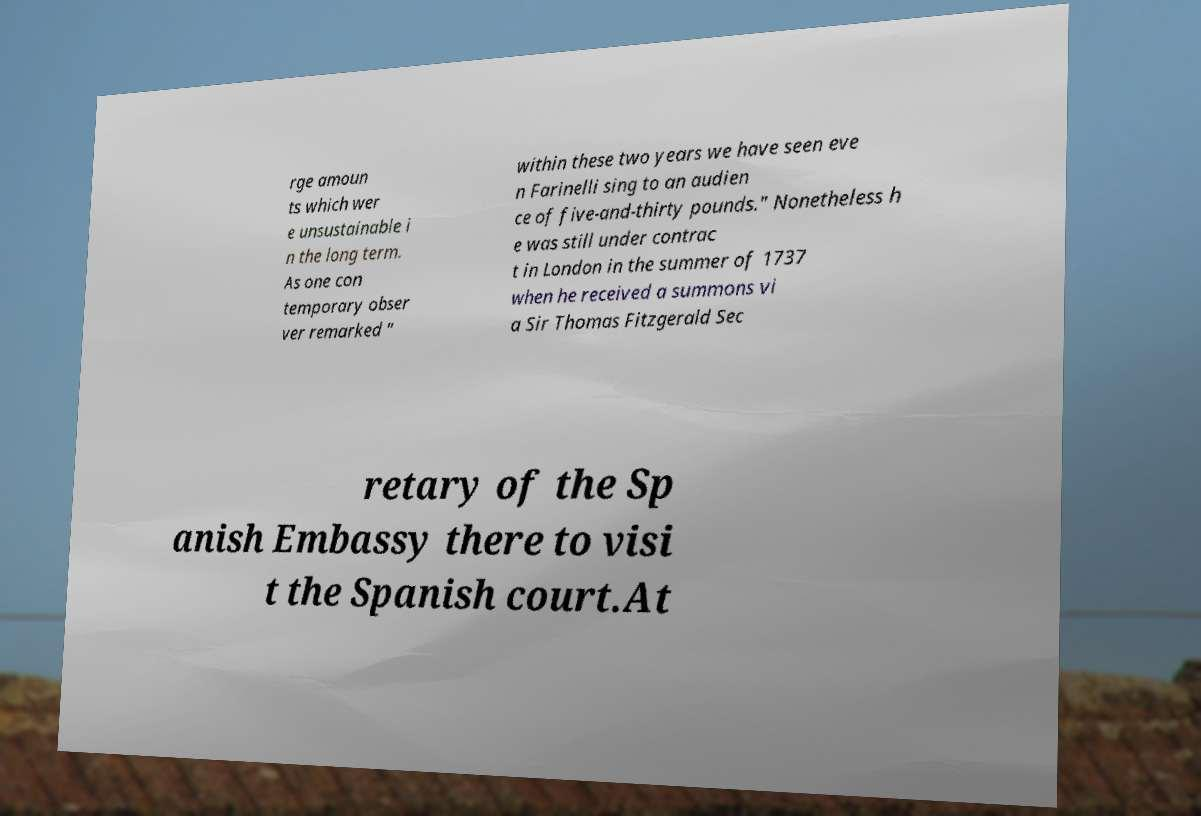Please identify and transcribe the text found in this image. rge amoun ts which wer e unsustainable i n the long term. As one con temporary obser ver remarked " within these two years we have seen eve n Farinelli sing to an audien ce of five-and-thirty pounds." Nonetheless h e was still under contrac t in London in the summer of 1737 when he received a summons vi a Sir Thomas Fitzgerald Sec retary of the Sp anish Embassy there to visi t the Spanish court.At 